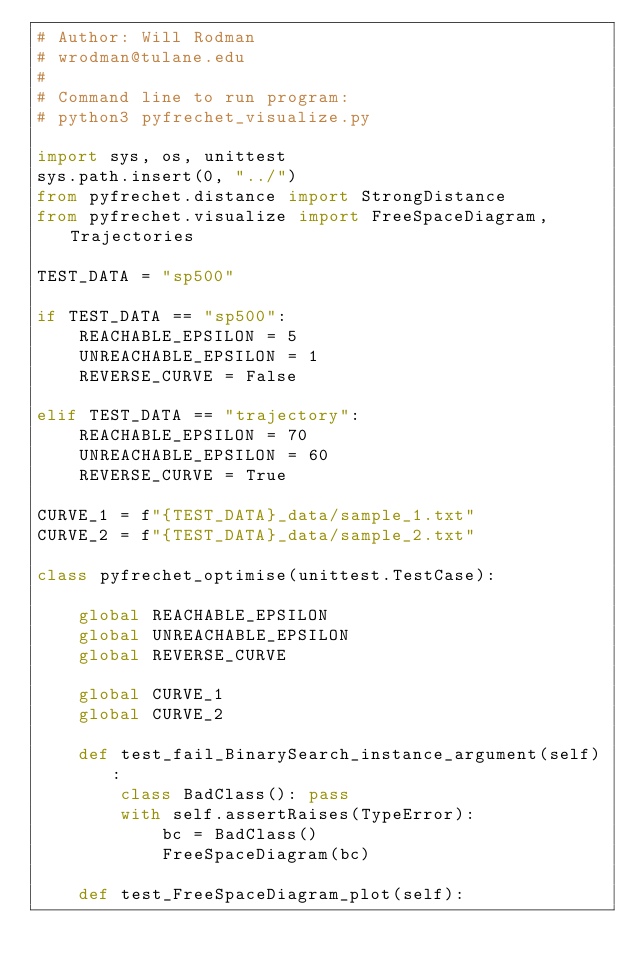Convert code to text. <code><loc_0><loc_0><loc_500><loc_500><_Python_># Author: Will Rodman
# wrodman@tulane.edu
#
# Command line to run program:
# python3 pyfrechet_visualize.py

import sys, os, unittest
sys.path.insert(0, "../")
from pyfrechet.distance import StrongDistance
from pyfrechet.visualize import FreeSpaceDiagram, Trajectories

TEST_DATA = "sp500"

if TEST_DATA == "sp500":
    REACHABLE_EPSILON = 5
    UNREACHABLE_EPSILON = 1
    REVERSE_CURVE = False

elif TEST_DATA == "trajectory":
    REACHABLE_EPSILON = 70
    UNREACHABLE_EPSILON = 60
    REVERSE_CURVE = True

CURVE_1 = f"{TEST_DATA}_data/sample_1.txt"
CURVE_2 = f"{TEST_DATA}_data/sample_2.txt"

class pyfrechet_optimise(unittest.TestCase):

    global REACHABLE_EPSILON
    global UNREACHABLE_EPSILON
    global REVERSE_CURVE

    global CURVE_1
    global CURVE_2

    def test_fail_BinarySearch_instance_argument(self):
        class BadClass(): pass
        with self.assertRaises(TypeError):
            bc = BadClass()
            FreeSpaceDiagram(bc)

    def test_FreeSpaceDiagram_plot(self):</code> 